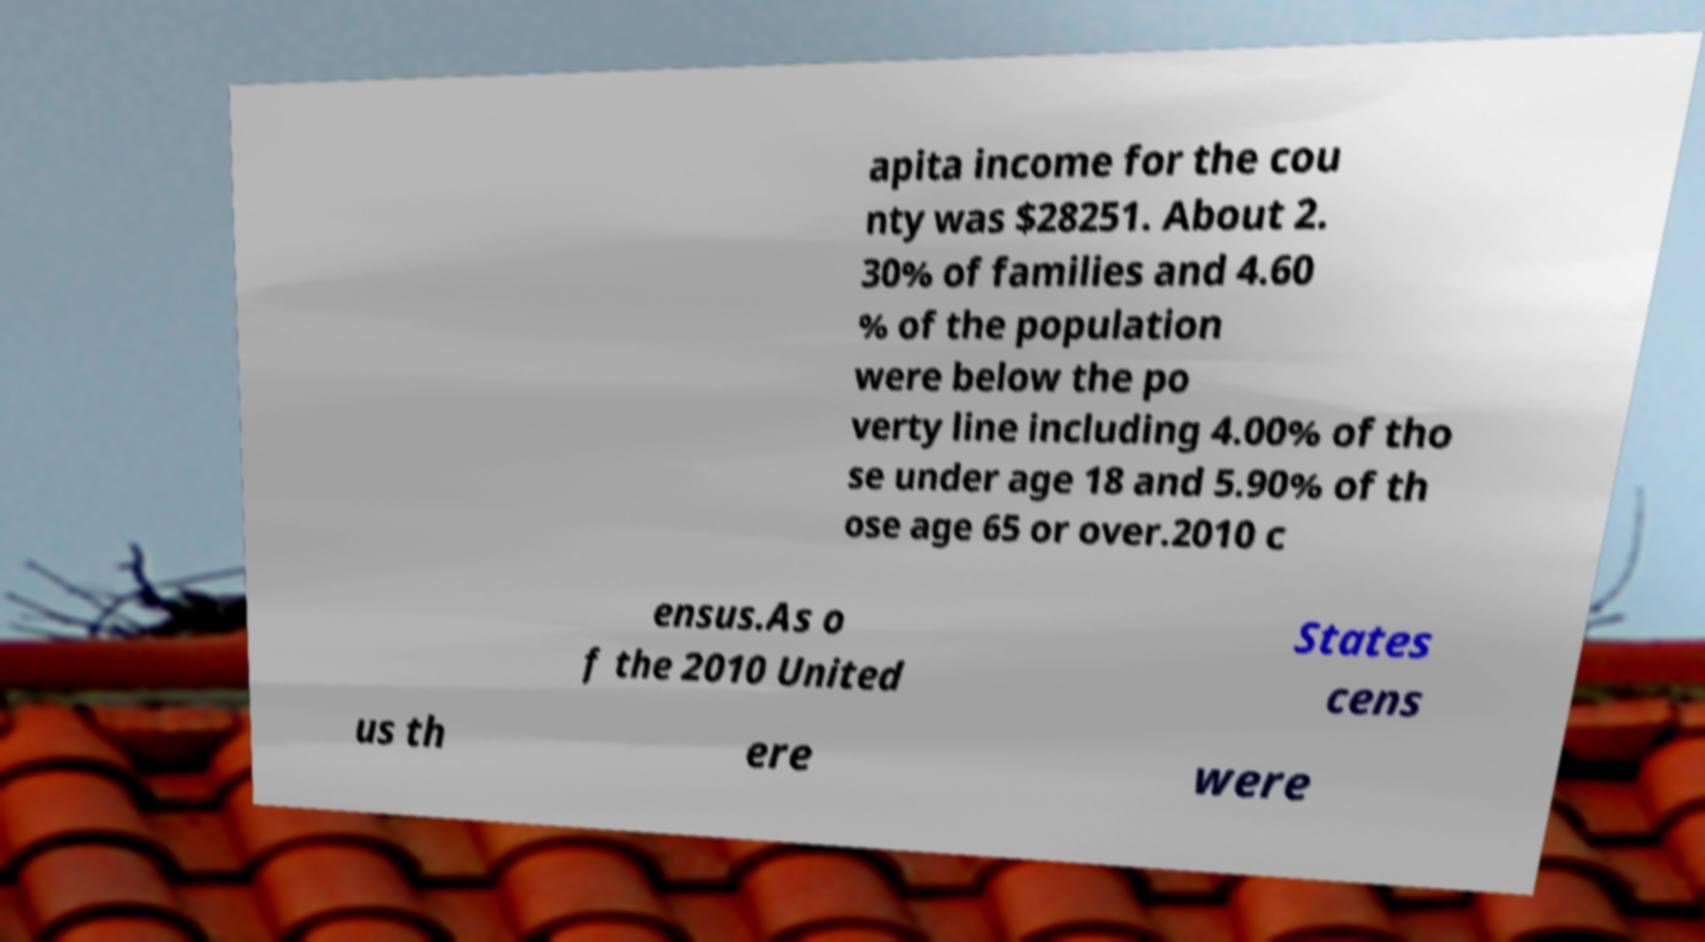Can you accurately transcribe the text from the provided image for me? apita income for the cou nty was $28251. About 2. 30% of families and 4.60 % of the population were below the po verty line including 4.00% of tho se under age 18 and 5.90% of th ose age 65 or over.2010 c ensus.As o f the 2010 United States cens us th ere were 